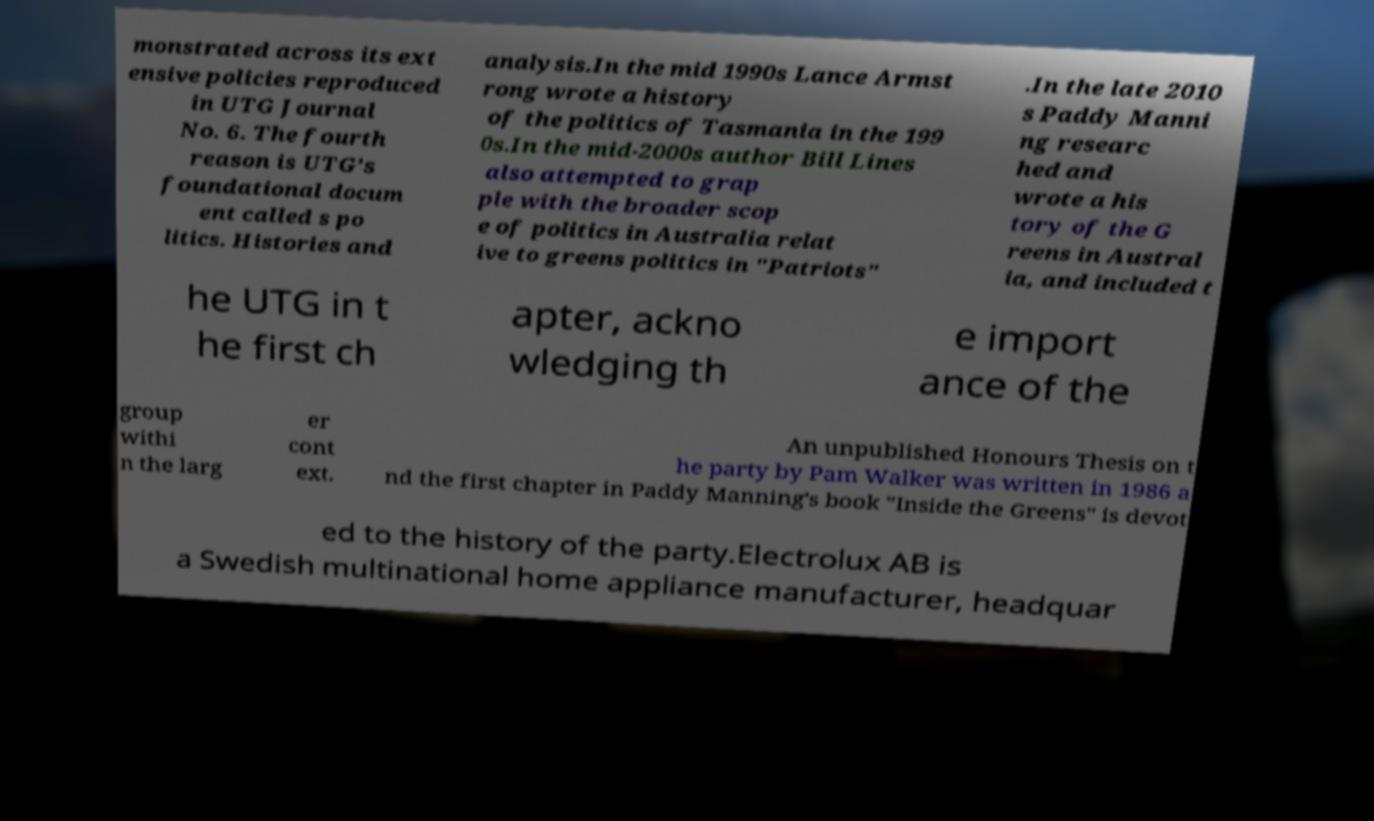Could you assist in decoding the text presented in this image and type it out clearly? monstrated across its ext ensive policies reproduced in UTG Journal No. 6. The fourth reason is UTG’s foundational docum ent called s po litics. Histories and analysis.In the mid 1990s Lance Armst rong wrote a history of the politics of Tasmania in the 199 0s.In the mid-2000s author Bill Lines also attempted to grap ple with the broader scop e of politics in Australia relat ive to greens politics in "Patriots" .In the late 2010 s Paddy Manni ng researc hed and wrote a his tory of the G reens in Austral ia, and included t he UTG in t he first ch apter, ackno wledging th e import ance of the group withi n the larg er cont ext. An unpublished Honours Thesis on t he party by Pam Walker was written in 1986 a nd the first chapter in Paddy Manning's book "Inside the Greens" is devot ed to the history of the party.Electrolux AB is a Swedish multinational home appliance manufacturer, headquar 